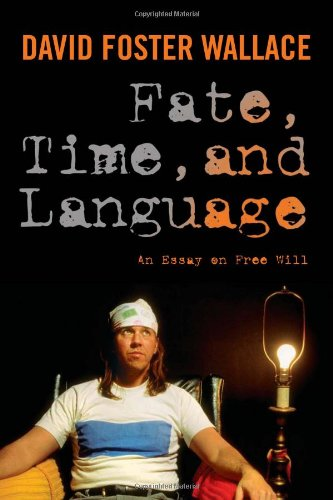Is this a games related book? No, this book does not focus on games; instead, it engages with philosophical inquiries and arguments related to free will and determinism. 